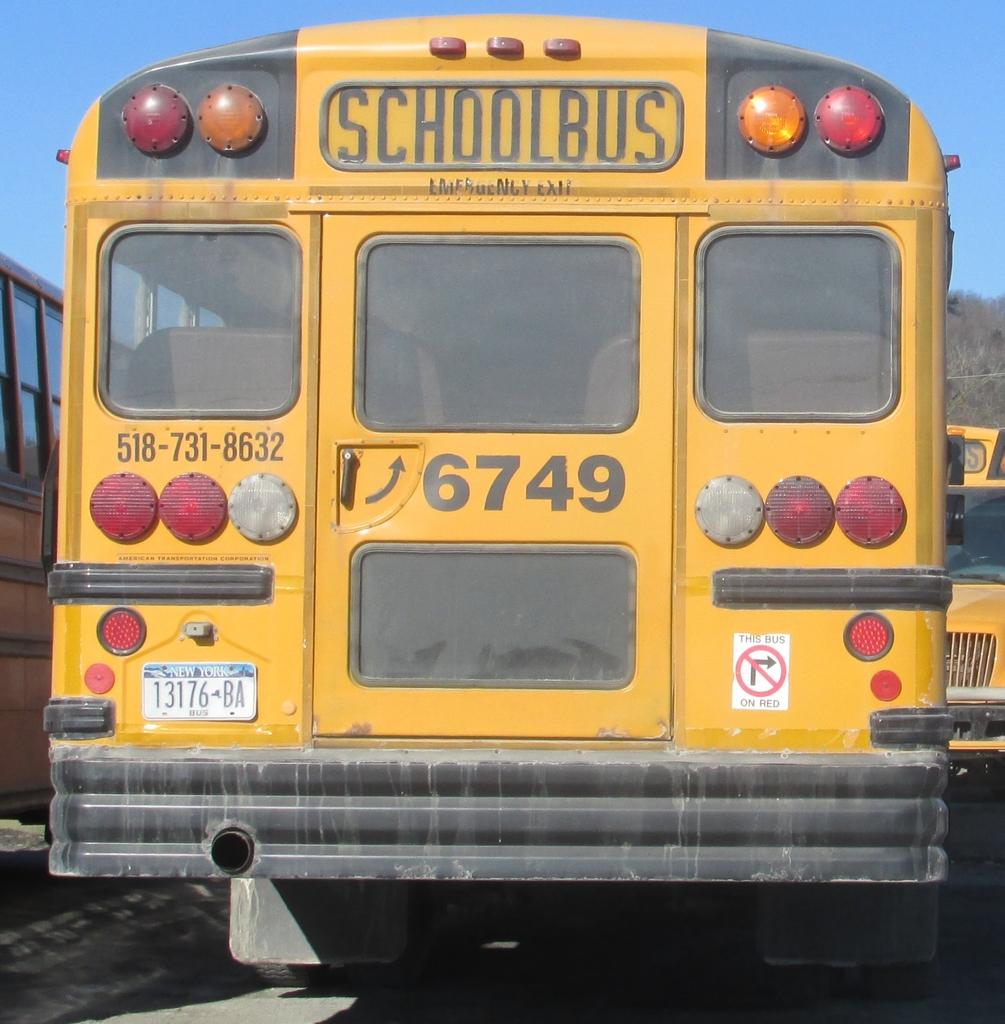What number is the schoolbus?
Keep it short and to the point. 6749. What state is the bus from?
Keep it short and to the point. New york. 